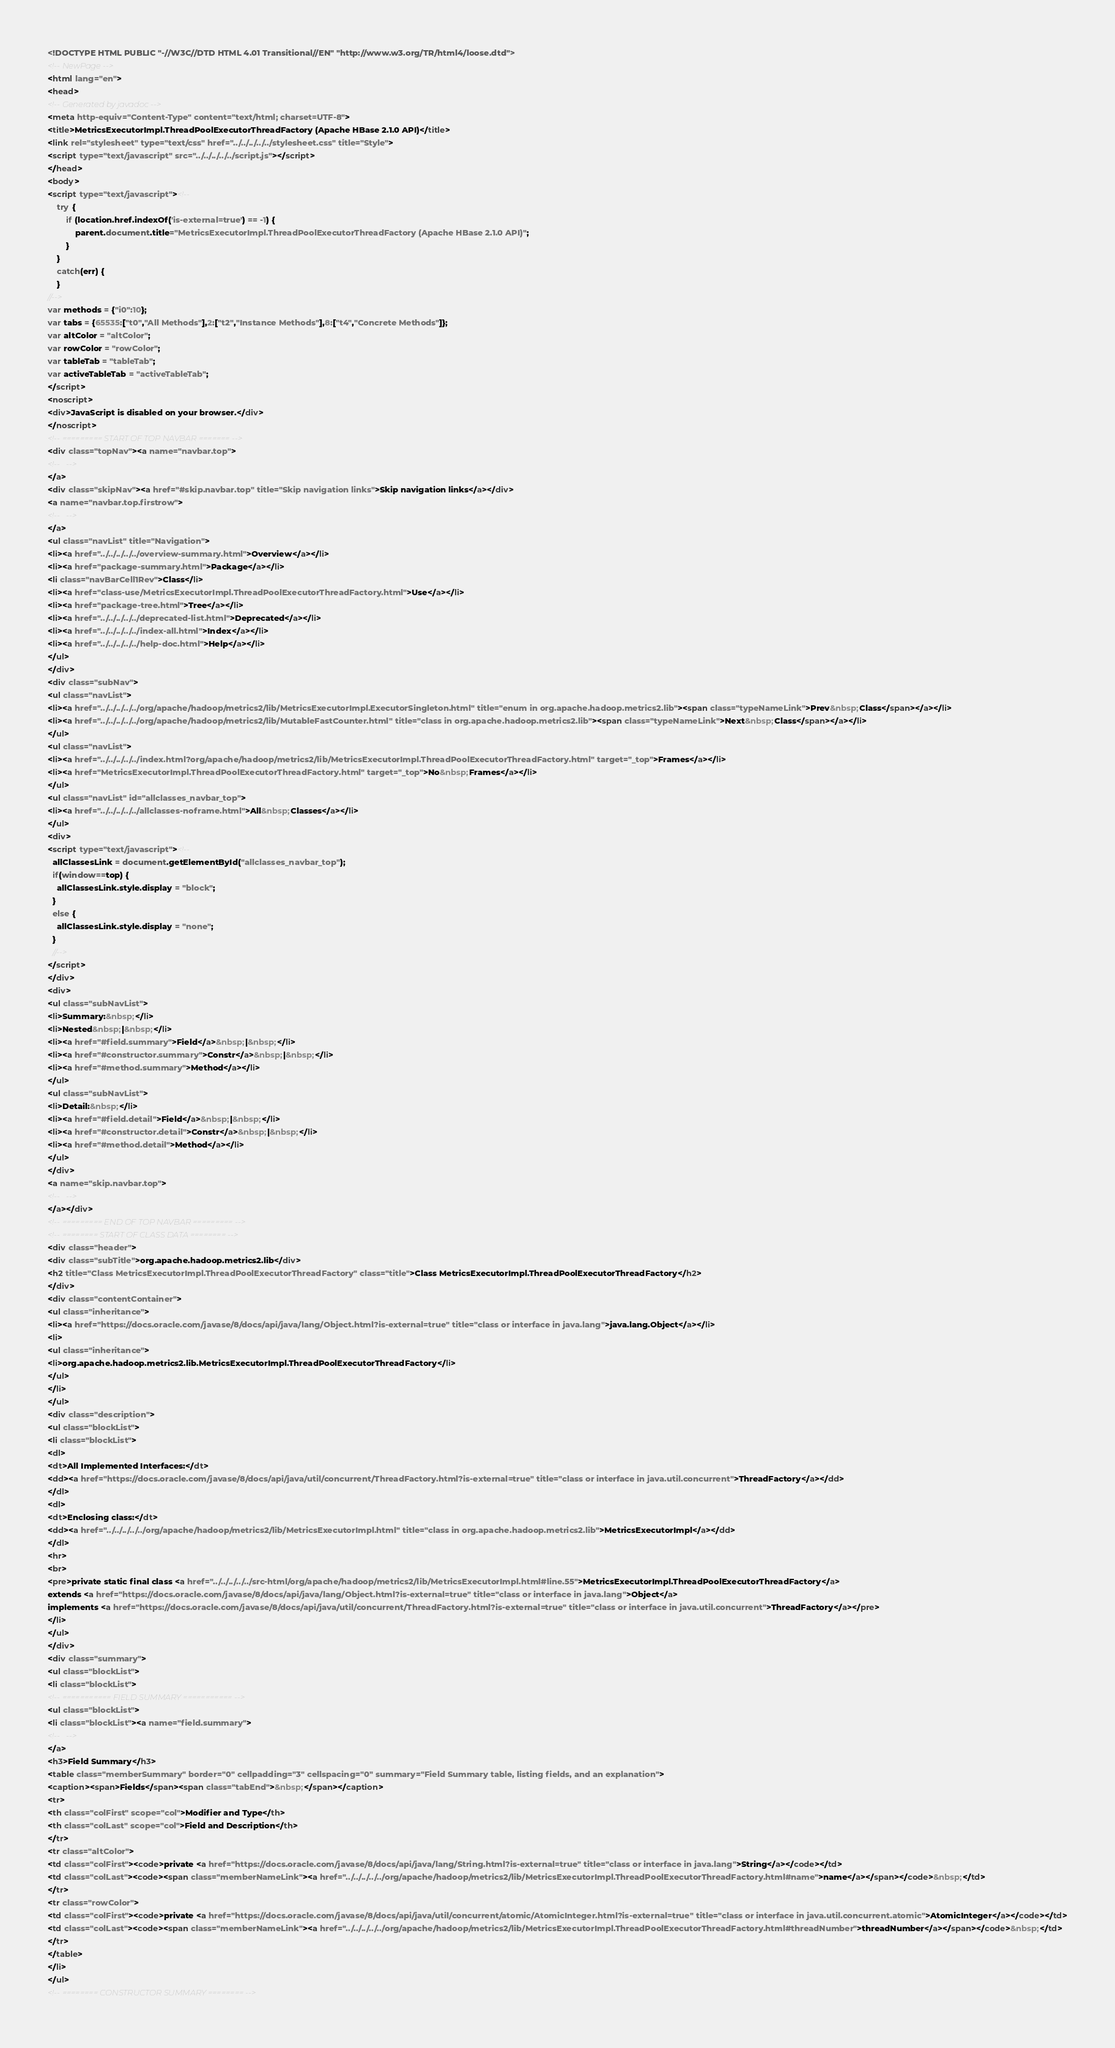<code> <loc_0><loc_0><loc_500><loc_500><_HTML_><!DOCTYPE HTML PUBLIC "-//W3C//DTD HTML 4.01 Transitional//EN" "http://www.w3.org/TR/html4/loose.dtd">
<!-- NewPage -->
<html lang="en">
<head>
<!-- Generated by javadoc -->
<meta http-equiv="Content-Type" content="text/html; charset=UTF-8">
<title>MetricsExecutorImpl.ThreadPoolExecutorThreadFactory (Apache HBase 2.1.0 API)</title>
<link rel="stylesheet" type="text/css" href="../../../../../stylesheet.css" title="Style">
<script type="text/javascript" src="../../../../../script.js"></script>
</head>
<body>
<script type="text/javascript"><!--
    try {
        if (location.href.indexOf('is-external=true') == -1) {
            parent.document.title="MetricsExecutorImpl.ThreadPoolExecutorThreadFactory (Apache HBase 2.1.0 API)";
        }
    }
    catch(err) {
    }
//-->
var methods = {"i0":10};
var tabs = {65535:["t0","All Methods"],2:["t2","Instance Methods"],8:["t4","Concrete Methods"]};
var altColor = "altColor";
var rowColor = "rowColor";
var tableTab = "tableTab";
var activeTableTab = "activeTableTab";
</script>
<noscript>
<div>JavaScript is disabled on your browser.</div>
</noscript>
<!-- ========= START OF TOP NAVBAR ======= -->
<div class="topNav"><a name="navbar.top">
<!--   -->
</a>
<div class="skipNav"><a href="#skip.navbar.top" title="Skip navigation links">Skip navigation links</a></div>
<a name="navbar.top.firstrow">
<!--   -->
</a>
<ul class="navList" title="Navigation">
<li><a href="../../../../../overview-summary.html">Overview</a></li>
<li><a href="package-summary.html">Package</a></li>
<li class="navBarCell1Rev">Class</li>
<li><a href="class-use/MetricsExecutorImpl.ThreadPoolExecutorThreadFactory.html">Use</a></li>
<li><a href="package-tree.html">Tree</a></li>
<li><a href="../../../../../deprecated-list.html">Deprecated</a></li>
<li><a href="../../../../../index-all.html">Index</a></li>
<li><a href="../../../../../help-doc.html">Help</a></li>
</ul>
</div>
<div class="subNav">
<ul class="navList">
<li><a href="../../../../../org/apache/hadoop/metrics2/lib/MetricsExecutorImpl.ExecutorSingleton.html" title="enum in org.apache.hadoop.metrics2.lib"><span class="typeNameLink">Prev&nbsp;Class</span></a></li>
<li><a href="../../../../../org/apache/hadoop/metrics2/lib/MutableFastCounter.html" title="class in org.apache.hadoop.metrics2.lib"><span class="typeNameLink">Next&nbsp;Class</span></a></li>
</ul>
<ul class="navList">
<li><a href="../../../../../index.html?org/apache/hadoop/metrics2/lib/MetricsExecutorImpl.ThreadPoolExecutorThreadFactory.html" target="_top">Frames</a></li>
<li><a href="MetricsExecutorImpl.ThreadPoolExecutorThreadFactory.html" target="_top">No&nbsp;Frames</a></li>
</ul>
<ul class="navList" id="allclasses_navbar_top">
<li><a href="../../../../../allclasses-noframe.html">All&nbsp;Classes</a></li>
</ul>
<div>
<script type="text/javascript"><!--
  allClassesLink = document.getElementById("allclasses_navbar_top");
  if(window==top) {
    allClassesLink.style.display = "block";
  }
  else {
    allClassesLink.style.display = "none";
  }
  //-->
</script>
</div>
<div>
<ul class="subNavList">
<li>Summary:&nbsp;</li>
<li>Nested&nbsp;|&nbsp;</li>
<li><a href="#field.summary">Field</a>&nbsp;|&nbsp;</li>
<li><a href="#constructor.summary">Constr</a>&nbsp;|&nbsp;</li>
<li><a href="#method.summary">Method</a></li>
</ul>
<ul class="subNavList">
<li>Detail:&nbsp;</li>
<li><a href="#field.detail">Field</a>&nbsp;|&nbsp;</li>
<li><a href="#constructor.detail">Constr</a>&nbsp;|&nbsp;</li>
<li><a href="#method.detail">Method</a></li>
</ul>
</div>
<a name="skip.navbar.top">
<!--   -->
</a></div>
<!-- ========= END OF TOP NAVBAR ========= -->
<!-- ======== START OF CLASS DATA ======== -->
<div class="header">
<div class="subTitle">org.apache.hadoop.metrics2.lib</div>
<h2 title="Class MetricsExecutorImpl.ThreadPoolExecutorThreadFactory" class="title">Class MetricsExecutorImpl.ThreadPoolExecutorThreadFactory</h2>
</div>
<div class="contentContainer">
<ul class="inheritance">
<li><a href="https://docs.oracle.com/javase/8/docs/api/java/lang/Object.html?is-external=true" title="class or interface in java.lang">java.lang.Object</a></li>
<li>
<ul class="inheritance">
<li>org.apache.hadoop.metrics2.lib.MetricsExecutorImpl.ThreadPoolExecutorThreadFactory</li>
</ul>
</li>
</ul>
<div class="description">
<ul class="blockList">
<li class="blockList">
<dl>
<dt>All Implemented Interfaces:</dt>
<dd><a href="https://docs.oracle.com/javase/8/docs/api/java/util/concurrent/ThreadFactory.html?is-external=true" title="class or interface in java.util.concurrent">ThreadFactory</a></dd>
</dl>
<dl>
<dt>Enclosing class:</dt>
<dd><a href="../../../../../org/apache/hadoop/metrics2/lib/MetricsExecutorImpl.html" title="class in org.apache.hadoop.metrics2.lib">MetricsExecutorImpl</a></dd>
</dl>
<hr>
<br>
<pre>private static final class <a href="../../../../../src-html/org/apache/hadoop/metrics2/lib/MetricsExecutorImpl.html#line.55">MetricsExecutorImpl.ThreadPoolExecutorThreadFactory</a>
extends <a href="https://docs.oracle.com/javase/8/docs/api/java/lang/Object.html?is-external=true" title="class or interface in java.lang">Object</a>
implements <a href="https://docs.oracle.com/javase/8/docs/api/java/util/concurrent/ThreadFactory.html?is-external=true" title="class or interface in java.util.concurrent">ThreadFactory</a></pre>
</li>
</ul>
</div>
<div class="summary">
<ul class="blockList">
<li class="blockList">
<!-- =========== FIELD SUMMARY =========== -->
<ul class="blockList">
<li class="blockList"><a name="field.summary">
<!--   -->
</a>
<h3>Field Summary</h3>
<table class="memberSummary" border="0" cellpadding="3" cellspacing="0" summary="Field Summary table, listing fields, and an explanation">
<caption><span>Fields</span><span class="tabEnd">&nbsp;</span></caption>
<tr>
<th class="colFirst" scope="col">Modifier and Type</th>
<th class="colLast" scope="col">Field and Description</th>
</tr>
<tr class="altColor">
<td class="colFirst"><code>private <a href="https://docs.oracle.com/javase/8/docs/api/java/lang/String.html?is-external=true" title="class or interface in java.lang">String</a></code></td>
<td class="colLast"><code><span class="memberNameLink"><a href="../../../../../org/apache/hadoop/metrics2/lib/MetricsExecutorImpl.ThreadPoolExecutorThreadFactory.html#name">name</a></span></code>&nbsp;</td>
</tr>
<tr class="rowColor">
<td class="colFirst"><code>private <a href="https://docs.oracle.com/javase/8/docs/api/java/util/concurrent/atomic/AtomicInteger.html?is-external=true" title="class or interface in java.util.concurrent.atomic">AtomicInteger</a></code></td>
<td class="colLast"><code><span class="memberNameLink"><a href="../../../../../org/apache/hadoop/metrics2/lib/MetricsExecutorImpl.ThreadPoolExecutorThreadFactory.html#threadNumber">threadNumber</a></span></code>&nbsp;</td>
</tr>
</table>
</li>
</ul>
<!-- ======== CONSTRUCTOR SUMMARY ======== --></code> 